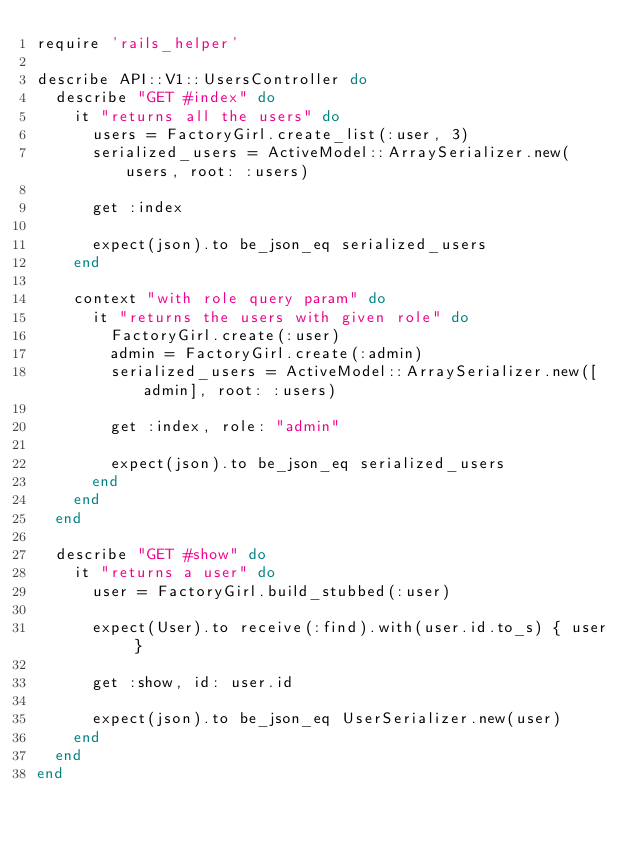Convert code to text. <code><loc_0><loc_0><loc_500><loc_500><_Ruby_>require 'rails_helper'

describe API::V1::UsersController do
  describe "GET #index" do
    it "returns all the users" do
      users = FactoryGirl.create_list(:user, 3)
      serialized_users = ActiveModel::ArraySerializer.new(users, root: :users)

      get :index

      expect(json).to be_json_eq serialized_users
    end

    context "with role query param" do
      it "returns the users with given role" do
        FactoryGirl.create(:user)
        admin = FactoryGirl.create(:admin)
        serialized_users = ActiveModel::ArraySerializer.new([admin], root: :users)

        get :index, role: "admin"

        expect(json).to be_json_eq serialized_users
      end
    end
  end

  describe "GET #show" do
    it "returns a user" do
      user = FactoryGirl.build_stubbed(:user)

      expect(User).to receive(:find).with(user.id.to_s) { user }

      get :show, id: user.id

      expect(json).to be_json_eq UserSerializer.new(user)
    end
  end
end
</code> 